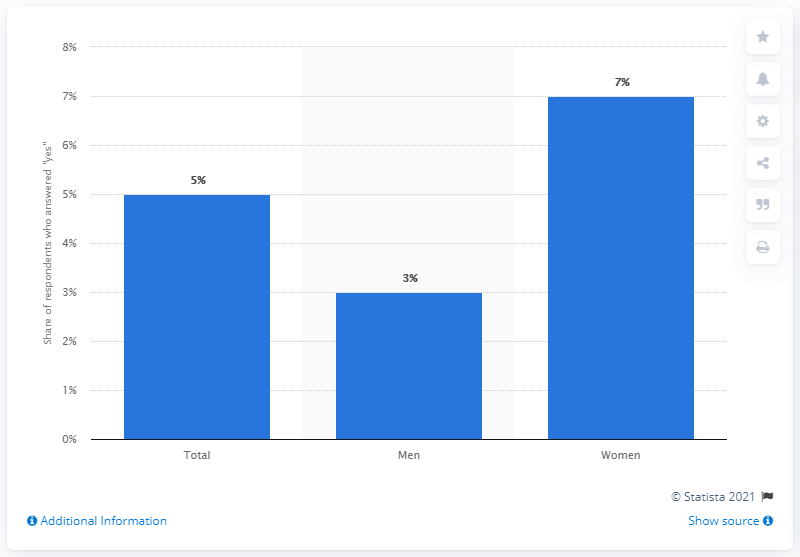Give some essential details in this illustration. A recent survey in Germany revealed that approximately 5% of the respondents identified as feminists. 